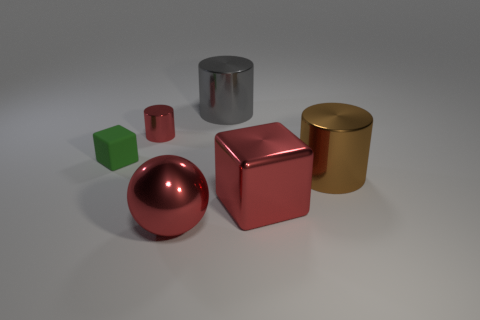Add 2 tiny blue metallic blocks. How many objects exist? 8 Subtract all balls. How many objects are left? 5 Subtract all gray shiny cylinders. Subtract all cylinders. How many objects are left? 2 Add 4 large red spheres. How many large red spheres are left? 5 Add 1 brown rubber cylinders. How many brown rubber cylinders exist? 1 Subtract 0 green balls. How many objects are left? 6 